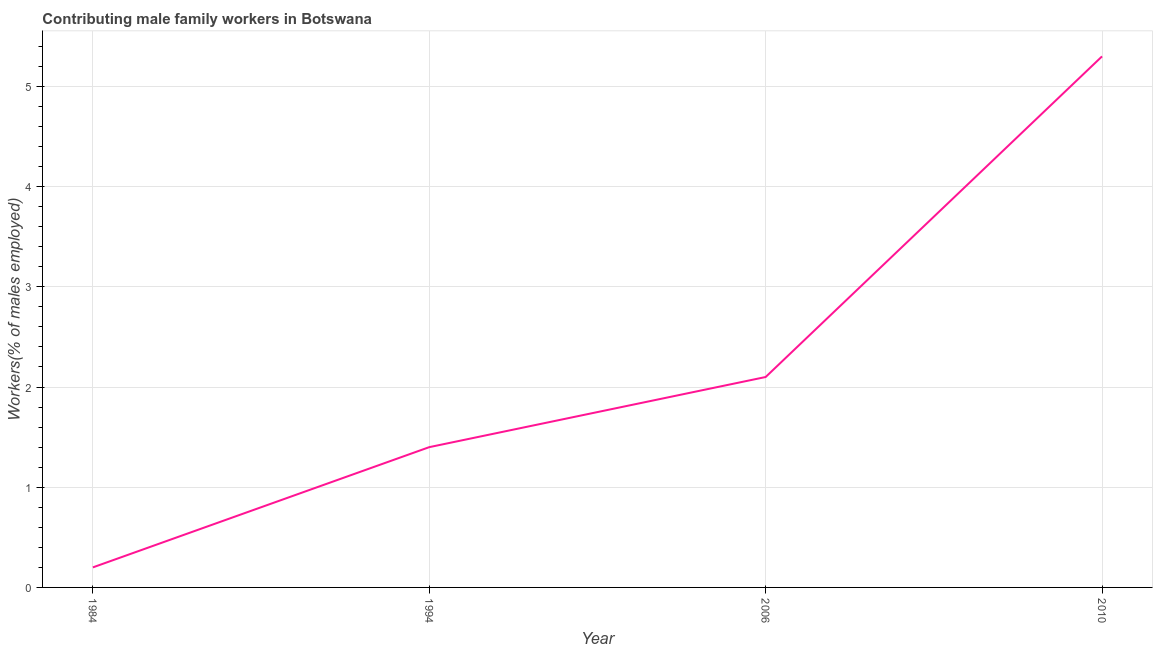What is the contributing male family workers in 2006?
Make the answer very short. 2.1. Across all years, what is the maximum contributing male family workers?
Provide a short and direct response. 5.3. Across all years, what is the minimum contributing male family workers?
Provide a short and direct response. 0.2. In which year was the contributing male family workers maximum?
Make the answer very short. 2010. In which year was the contributing male family workers minimum?
Ensure brevity in your answer.  1984. What is the sum of the contributing male family workers?
Give a very brief answer. 9. What is the difference between the contributing male family workers in 1984 and 1994?
Your answer should be very brief. -1.2. What is the average contributing male family workers per year?
Provide a short and direct response. 2.25. What is the median contributing male family workers?
Your answer should be compact. 1.75. Do a majority of the years between 2010 and 1994 (inclusive) have contributing male family workers greater than 4.2 %?
Offer a very short reply. No. What is the ratio of the contributing male family workers in 2006 to that in 2010?
Give a very brief answer. 0.4. What is the difference between the highest and the second highest contributing male family workers?
Offer a terse response. 3.2. Is the sum of the contributing male family workers in 1994 and 2010 greater than the maximum contributing male family workers across all years?
Provide a short and direct response. Yes. What is the difference between the highest and the lowest contributing male family workers?
Offer a terse response. 5.1. Does the contributing male family workers monotonically increase over the years?
Make the answer very short. Yes. How many lines are there?
Give a very brief answer. 1. How many years are there in the graph?
Your answer should be compact. 4. Are the values on the major ticks of Y-axis written in scientific E-notation?
Your answer should be very brief. No. Does the graph contain any zero values?
Provide a short and direct response. No. What is the title of the graph?
Provide a succinct answer. Contributing male family workers in Botswana. What is the label or title of the X-axis?
Offer a very short reply. Year. What is the label or title of the Y-axis?
Ensure brevity in your answer.  Workers(% of males employed). What is the Workers(% of males employed) in 1984?
Provide a succinct answer. 0.2. What is the Workers(% of males employed) of 1994?
Provide a short and direct response. 1.4. What is the Workers(% of males employed) of 2006?
Your response must be concise. 2.1. What is the Workers(% of males employed) in 2010?
Offer a very short reply. 5.3. What is the difference between the Workers(% of males employed) in 1984 and 1994?
Your answer should be very brief. -1.2. What is the difference between the Workers(% of males employed) in 1984 and 2006?
Your answer should be very brief. -1.9. What is the difference between the Workers(% of males employed) in 1994 and 2006?
Your answer should be compact. -0.7. What is the difference between the Workers(% of males employed) in 1994 and 2010?
Keep it short and to the point. -3.9. What is the difference between the Workers(% of males employed) in 2006 and 2010?
Give a very brief answer. -3.2. What is the ratio of the Workers(% of males employed) in 1984 to that in 1994?
Your response must be concise. 0.14. What is the ratio of the Workers(% of males employed) in 1984 to that in 2006?
Provide a short and direct response. 0.1. What is the ratio of the Workers(% of males employed) in 1984 to that in 2010?
Offer a very short reply. 0.04. What is the ratio of the Workers(% of males employed) in 1994 to that in 2006?
Provide a short and direct response. 0.67. What is the ratio of the Workers(% of males employed) in 1994 to that in 2010?
Offer a terse response. 0.26. What is the ratio of the Workers(% of males employed) in 2006 to that in 2010?
Provide a succinct answer. 0.4. 